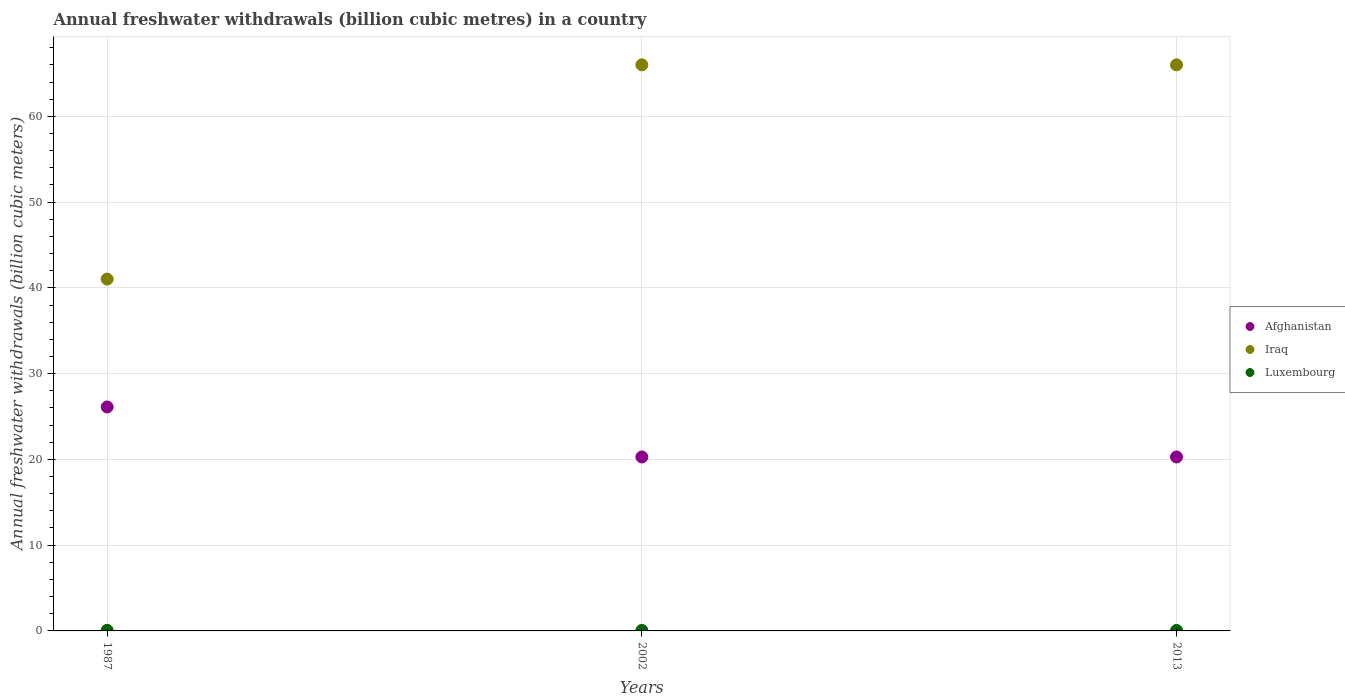Is the number of dotlines equal to the number of legend labels?
Offer a very short reply. Yes. What is the annual freshwater withdrawals in Iraq in 1987?
Ensure brevity in your answer.  41.02. Across all years, what is the maximum annual freshwater withdrawals in Afghanistan?
Provide a short and direct response. 26.11. Across all years, what is the minimum annual freshwater withdrawals in Luxembourg?
Your response must be concise. 0.06. In which year was the annual freshwater withdrawals in Afghanistan minimum?
Your response must be concise. 2002. What is the total annual freshwater withdrawals in Luxembourg in the graph?
Your answer should be very brief. 0.19. What is the difference between the annual freshwater withdrawals in Afghanistan in 2002 and that in 2013?
Make the answer very short. 0. What is the difference between the annual freshwater withdrawals in Iraq in 2002 and the annual freshwater withdrawals in Afghanistan in 1987?
Provide a short and direct response. 39.89. What is the average annual freshwater withdrawals in Luxembourg per year?
Your response must be concise. 0.06. In the year 2013, what is the difference between the annual freshwater withdrawals in Luxembourg and annual freshwater withdrawals in Iraq?
Your answer should be very brief. -65.94. In how many years, is the annual freshwater withdrawals in Luxembourg greater than 56 billion cubic meters?
Your answer should be very brief. 0. What is the ratio of the annual freshwater withdrawals in Afghanistan in 1987 to that in 2002?
Make the answer very short. 1.29. What is the difference between the highest and the second highest annual freshwater withdrawals in Afghanistan?
Give a very brief answer. 5.83. What is the difference between the highest and the lowest annual freshwater withdrawals in Iraq?
Provide a succinct answer. 24.98. In how many years, is the annual freshwater withdrawals in Luxembourg greater than the average annual freshwater withdrawals in Luxembourg taken over all years?
Give a very brief answer. 1. Is the sum of the annual freshwater withdrawals in Afghanistan in 2002 and 2013 greater than the maximum annual freshwater withdrawals in Luxembourg across all years?
Provide a succinct answer. Yes. Is it the case that in every year, the sum of the annual freshwater withdrawals in Iraq and annual freshwater withdrawals in Afghanistan  is greater than the annual freshwater withdrawals in Luxembourg?
Ensure brevity in your answer.  Yes. How many dotlines are there?
Offer a very short reply. 3. How many years are there in the graph?
Your response must be concise. 3. Are the values on the major ticks of Y-axis written in scientific E-notation?
Offer a very short reply. No. Does the graph contain any zero values?
Your response must be concise. No. Does the graph contain grids?
Give a very brief answer. Yes. Where does the legend appear in the graph?
Offer a very short reply. Center right. How many legend labels are there?
Your answer should be very brief. 3. What is the title of the graph?
Your response must be concise. Annual freshwater withdrawals (billion cubic metres) in a country. What is the label or title of the X-axis?
Give a very brief answer. Years. What is the label or title of the Y-axis?
Provide a succinct answer. Annual freshwater withdrawals (billion cubic meters). What is the Annual freshwater withdrawals (billion cubic meters) of Afghanistan in 1987?
Your answer should be compact. 26.11. What is the Annual freshwater withdrawals (billion cubic meters) in Iraq in 1987?
Your answer should be very brief. 41.02. What is the Annual freshwater withdrawals (billion cubic meters) of Luxembourg in 1987?
Give a very brief answer. 0.07. What is the Annual freshwater withdrawals (billion cubic meters) in Afghanistan in 2002?
Provide a succinct answer. 20.28. What is the Annual freshwater withdrawals (billion cubic meters) in Iraq in 2002?
Your answer should be very brief. 66. What is the Annual freshwater withdrawals (billion cubic meters) in Luxembourg in 2002?
Offer a terse response. 0.06. What is the Annual freshwater withdrawals (billion cubic meters) in Afghanistan in 2013?
Keep it short and to the point. 20.28. What is the Annual freshwater withdrawals (billion cubic meters) of Iraq in 2013?
Make the answer very short. 66. What is the Annual freshwater withdrawals (billion cubic meters) in Luxembourg in 2013?
Your answer should be very brief. 0.06. Across all years, what is the maximum Annual freshwater withdrawals (billion cubic meters) in Afghanistan?
Keep it short and to the point. 26.11. Across all years, what is the maximum Annual freshwater withdrawals (billion cubic meters) in Iraq?
Give a very brief answer. 66. Across all years, what is the maximum Annual freshwater withdrawals (billion cubic meters) in Luxembourg?
Provide a short and direct response. 0.07. Across all years, what is the minimum Annual freshwater withdrawals (billion cubic meters) of Afghanistan?
Provide a short and direct response. 20.28. Across all years, what is the minimum Annual freshwater withdrawals (billion cubic meters) of Iraq?
Offer a terse response. 41.02. Across all years, what is the minimum Annual freshwater withdrawals (billion cubic meters) of Luxembourg?
Ensure brevity in your answer.  0.06. What is the total Annual freshwater withdrawals (billion cubic meters) in Afghanistan in the graph?
Provide a succinct answer. 66.67. What is the total Annual freshwater withdrawals (billion cubic meters) of Iraq in the graph?
Your answer should be compact. 173.02. What is the total Annual freshwater withdrawals (billion cubic meters) in Luxembourg in the graph?
Your answer should be very brief. 0.19. What is the difference between the Annual freshwater withdrawals (billion cubic meters) in Afghanistan in 1987 and that in 2002?
Offer a very short reply. 5.83. What is the difference between the Annual freshwater withdrawals (billion cubic meters) of Iraq in 1987 and that in 2002?
Give a very brief answer. -24.98. What is the difference between the Annual freshwater withdrawals (billion cubic meters) in Luxembourg in 1987 and that in 2002?
Provide a short and direct response. 0.01. What is the difference between the Annual freshwater withdrawals (billion cubic meters) of Afghanistan in 1987 and that in 2013?
Your answer should be compact. 5.83. What is the difference between the Annual freshwater withdrawals (billion cubic meters) of Iraq in 1987 and that in 2013?
Offer a terse response. -24.98. What is the difference between the Annual freshwater withdrawals (billion cubic meters) of Luxembourg in 1987 and that in 2013?
Your response must be concise. 0.01. What is the difference between the Annual freshwater withdrawals (billion cubic meters) in Afghanistan in 2002 and that in 2013?
Provide a succinct answer. 0. What is the difference between the Annual freshwater withdrawals (billion cubic meters) of Iraq in 2002 and that in 2013?
Offer a terse response. 0. What is the difference between the Annual freshwater withdrawals (billion cubic meters) in Luxembourg in 2002 and that in 2013?
Your response must be concise. 0. What is the difference between the Annual freshwater withdrawals (billion cubic meters) in Afghanistan in 1987 and the Annual freshwater withdrawals (billion cubic meters) in Iraq in 2002?
Your answer should be compact. -39.89. What is the difference between the Annual freshwater withdrawals (billion cubic meters) in Afghanistan in 1987 and the Annual freshwater withdrawals (billion cubic meters) in Luxembourg in 2002?
Make the answer very short. 26.05. What is the difference between the Annual freshwater withdrawals (billion cubic meters) in Iraq in 1987 and the Annual freshwater withdrawals (billion cubic meters) in Luxembourg in 2002?
Give a very brief answer. 40.96. What is the difference between the Annual freshwater withdrawals (billion cubic meters) in Afghanistan in 1987 and the Annual freshwater withdrawals (billion cubic meters) in Iraq in 2013?
Keep it short and to the point. -39.89. What is the difference between the Annual freshwater withdrawals (billion cubic meters) of Afghanistan in 1987 and the Annual freshwater withdrawals (billion cubic meters) of Luxembourg in 2013?
Provide a succinct answer. 26.05. What is the difference between the Annual freshwater withdrawals (billion cubic meters) of Iraq in 1987 and the Annual freshwater withdrawals (billion cubic meters) of Luxembourg in 2013?
Make the answer very short. 40.96. What is the difference between the Annual freshwater withdrawals (billion cubic meters) of Afghanistan in 2002 and the Annual freshwater withdrawals (billion cubic meters) of Iraq in 2013?
Your response must be concise. -45.72. What is the difference between the Annual freshwater withdrawals (billion cubic meters) in Afghanistan in 2002 and the Annual freshwater withdrawals (billion cubic meters) in Luxembourg in 2013?
Your response must be concise. 20.22. What is the difference between the Annual freshwater withdrawals (billion cubic meters) of Iraq in 2002 and the Annual freshwater withdrawals (billion cubic meters) of Luxembourg in 2013?
Keep it short and to the point. 65.94. What is the average Annual freshwater withdrawals (billion cubic meters) of Afghanistan per year?
Give a very brief answer. 22.22. What is the average Annual freshwater withdrawals (billion cubic meters) in Iraq per year?
Keep it short and to the point. 57.67. What is the average Annual freshwater withdrawals (billion cubic meters) in Luxembourg per year?
Your answer should be very brief. 0.06. In the year 1987, what is the difference between the Annual freshwater withdrawals (billion cubic meters) in Afghanistan and Annual freshwater withdrawals (billion cubic meters) in Iraq?
Give a very brief answer. -14.91. In the year 1987, what is the difference between the Annual freshwater withdrawals (billion cubic meters) of Afghanistan and Annual freshwater withdrawals (billion cubic meters) of Luxembourg?
Provide a short and direct response. 26.04. In the year 1987, what is the difference between the Annual freshwater withdrawals (billion cubic meters) in Iraq and Annual freshwater withdrawals (billion cubic meters) in Luxembourg?
Your response must be concise. 40.95. In the year 2002, what is the difference between the Annual freshwater withdrawals (billion cubic meters) in Afghanistan and Annual freshwater withdrawals (billion cubic meters) in Iraq?
Your answer should be very brief. -45.72. In the year 2002, what is the difference between the Annual freshwater withdrawals (billion cubic meters) in Afghanistan and Annual freshwater withdrawals (billion cubic meters) in Luxembourg?
Provide a short and direct response. 20.22. In the year 2002, what is the difference between the Annual freshwater withdrawals (billion cubic meters) in Iraq and Annual freshwater withdrawals (billion cubic meters) in Luxembourg?
Your answer should be very brief. 65.94. In the year 2013, what is the difference between the Annual freshwater withdrawals (billion cubic meters) of Afghanistan and Annual freshwater withdrawals (billion cubic meters) of Iraq?
Provide a short and direct response. -45.72. In the year 2013, what is the difference between the Annual freshwater withdrawals (billion cubic meters) in Afghanistan and Annual freshwater withdrawals (billion cubic meters) in Luxembourg?
Offer a terse response. 20.22. In the year 2013, what is the difference between the Annual freshwater withdrawals (billion cubic meters) in Iraq and Annual freshwater withdrawals (billion cubic meters) in Luxembourg?
Your answer should be compact. 65.94. What is the ratio of the Annual freshwater withdrawals (billion cubic meters) of Afghanistan in 1987 to that in 2002?
Your response must be concise. 1.29. What is the ratio of the Annual freshwater withdrawals (billion cubic meters) of Iraq in 1987 to that in 2002?
Keep it short and to the point. 0.62. What is the ratio of the Annual freshwater withdrawals (billion cubic meters) of Luxembourg in 1987 to that in 2002?
Give a very brief answer. 1.11. What is the ratio of the Annual freshwater withdrawals (billion cubic meters) in Afghanistan in 1987 to that in 2013?
Provide a short and direct response. 1.29. What is the ratio of the Annual freshwater withdrawals (billion cubic meters) in Iraq in 1987 to that in 2013?
Give a very brief answer. 0.62. What is the ratio of the Annual freshwater withdrawals (billion cubic meters) of Luxembourg in 1987 to that in 2013?
Ensure brevity in your answer.  1.11. What is the ratio of the Annual freshwater withdrawals (billion cubic meters) in Afghanistan in 2002 to that in 2013?
Your response must be concise. 1. What is the ratio of the Annual freshwater withdrawals (billion cubic meters) of Iraq in 2002 to that in 2013?
Make the answer very short. 1. What is the ratio of the Annual freshwater withdrawals (billion cubic meters) of Luxembourg in 2002 to that in 2013?
Offer a terse response. 1. What is the difference between the highest and the second highest Annual freshwater withdrawals (billion cubic meters) of Afghanistan?
Offer a very short reply. 5.83. What is the difference between the highest and the second highest Annual freshwater withdrawals (billion cubic meters) in Luxembourg?
Keep it short and to the point. 0.01. What is the difference between the highest and the lowest Annual freshwater withdrawals (billion cubic meters) of Afghanistan?
Give a very brief answer. 5.83. What is the difference between the highest and the lowest Annual freshwater withdrawals (billion cubic meters) in Iraq?
Your answer should be compact. 24.98. What is the difference between the highest and the lowest Annual freshwater withdrawals (billion cubic meters) in Luxembourg?
Make the answer very short. 0.01. 